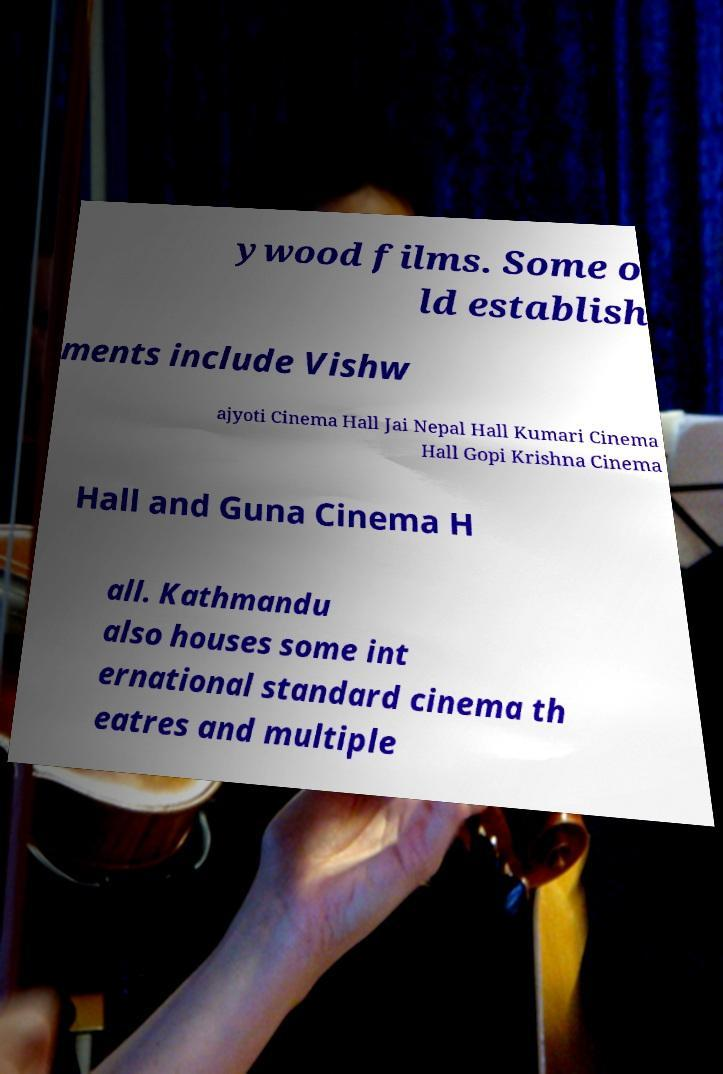Please read and relay the text visible in this image. What does it say? ywood films. Some o ld establish ments include Vishw ajyoti Cinema Hall Jai Nepal Hall Kumari Cinema Hall Gopi Krishna Cinema Hall and Guna Cinema H all. Kathmandu also houses some int ernational standard cinema th eatres and multiple 